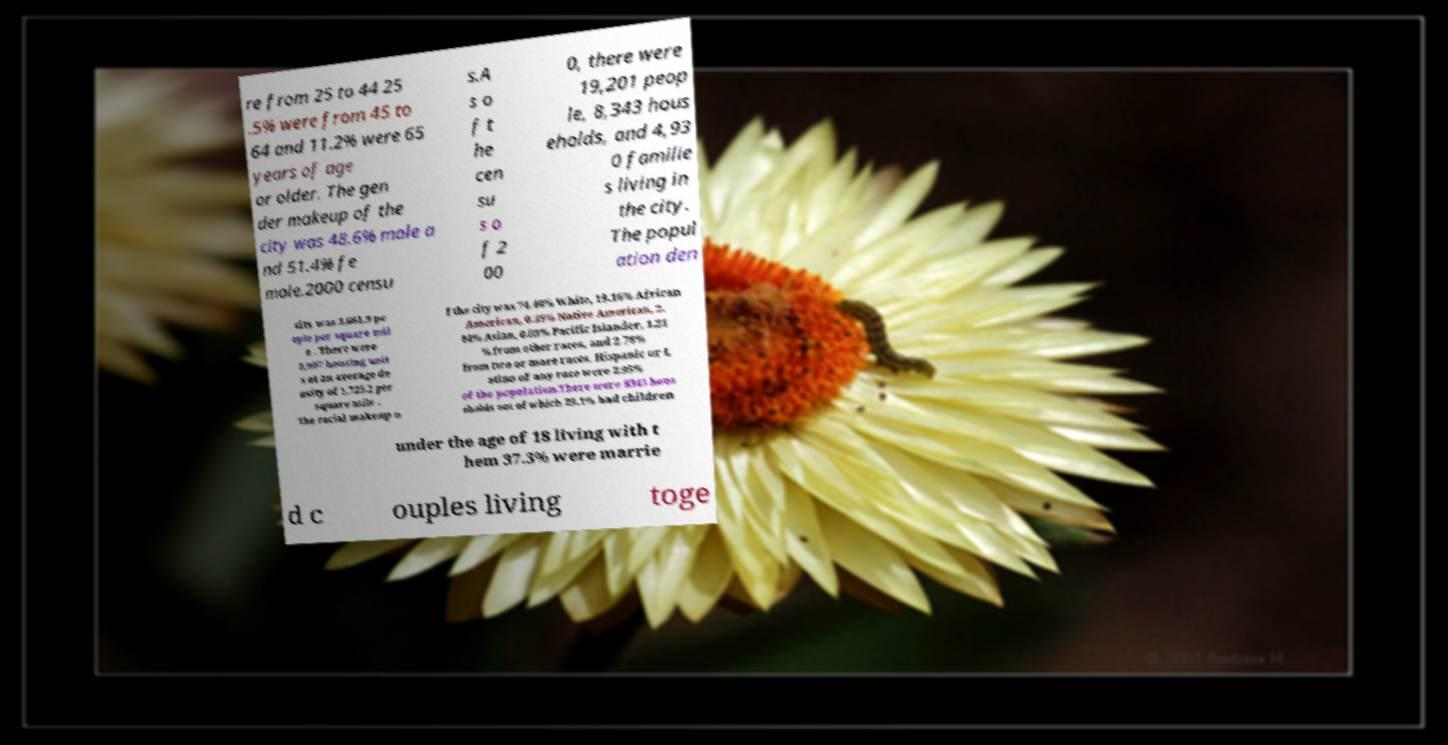Can you accurately transcribe the text from the provided image for me? re from 25 to 44 25 .5% were from 45 to 64 and 11.2% were 65 years of age or older. The gen der makeup of the city was 48.6% male a nd 51.4% fe male.2000 censu s.A s o f t he cen su s o f 2 00 0, there were 19,201 peop le, 8,343 hous eholds, and 4,93 0 familie s living in the city. The popul ation den sity was 3,681.9 pe ople per square mil e . There were 8,997 housing unit s at an average de nsity of 1,725.2 per square mile . The racial makeup o f the city was 74.40% White, 19.16% African American, 0.39% Native American, 2. 04% Asian, 0.03% Pacific Islander, 1.21 % from other races, and 2.78% from two or more races. Hispanic or L atino of any race were 2.95% of the population.There were 8343 hous eholds out of which 29.1% had children under the age of 18 living with t hem 37.3% were marrie d c ouples living toge 